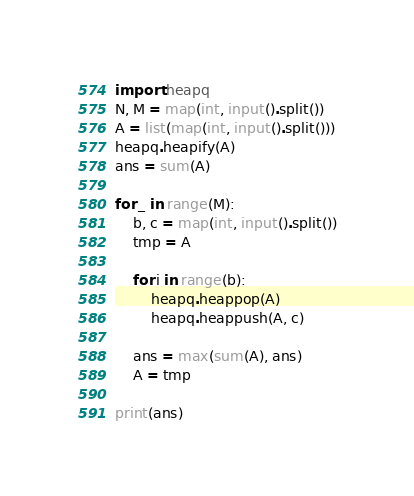Convert code to text. <code><loc_0><loc_0><loc_500><loc_500><_Python_>import heapq
N, M = map(int, input().split())
A = list(map(int, input().split()))
heapq.heapify(A)
ans = sum(A)

for _ in range(M):
    b, c = map(int, input().split())
    tmp = A

    for i in range(b):
        heapq.heappop(A)
        heapq.heappush(A, c)
    
    ans = max(sum(A), ans)
    A = tmp

print(ans)</code> 